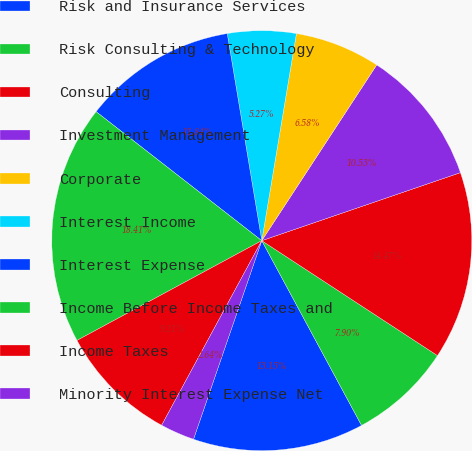Convert chart. <chart><loc_0><loc_0><loc_500><loc_500><pie_chart><fcel>Risk and Insurance Services<fcel>Risk Consulting & Technology<fcel>Consulting<fcel>Investment Management<fcel>Corporate<fcel>Interest Income<fcel>Interest Expense<fcel>Income Before Income Taxes and<fcel>Income Taxes<fcel>Minority Interest Expense Net<nl><fcel>13.15%<fcel>7.9%<fcel>14.47%<fcel>10.53%<fcel>6.58%<fcel>5.27%<fcel>11.84%<fcel>18.41%<fcel>9.21%<fcel>2.64%<nl></chart> 